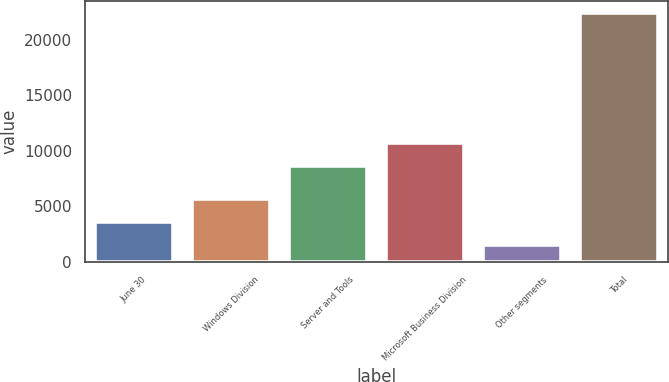<chart> <loc_0><loc_0><loc_500><loc_500><bar_chart><fcel>June 30<fcel>Windows Division<fcel>Server and Tools<fcel>Microsoft Business Division<fcel>Other segments<fcel>Total<nl><fcel>3618.7<fcel>5705.4<fcel>8639<fcel>10725.7<fcel>1532<fcel>22399<nl></chart> 